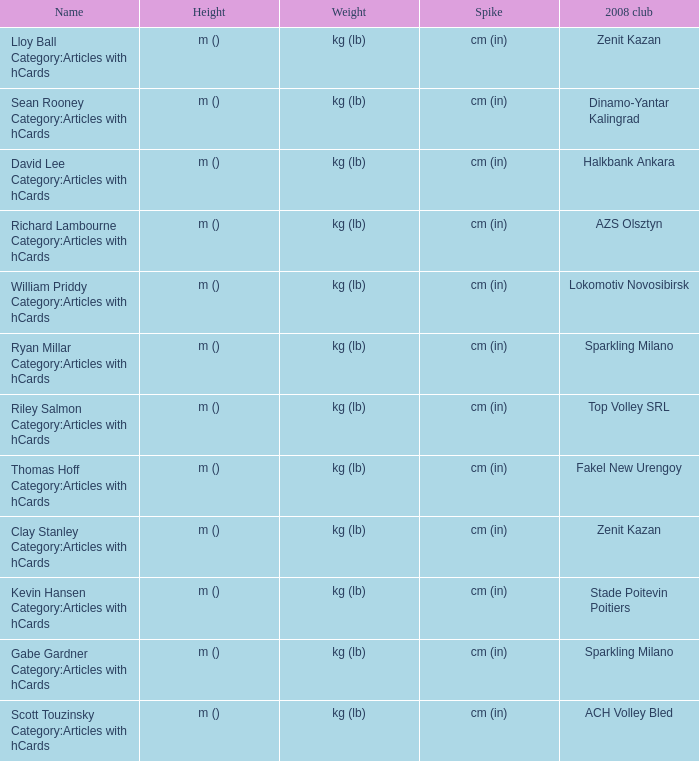What is the spike for the 2008 club of Lokomotiv Novosibirsk? Cm (in). 